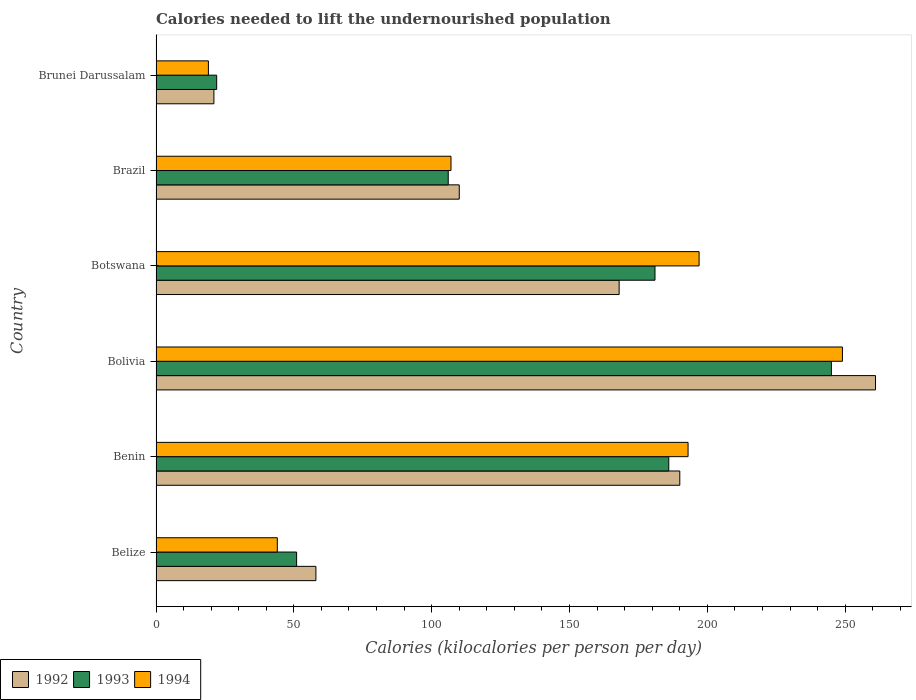How many different coloured bars are there?
Give a very brief answer. 3. How many groups of bars are there?
Keep it short and to the point. 6. Are the number of bars per tick equal to the number of legend labels?
Offer a terse response. Yes. Are the number of bars on each tick of the Y-axis equal?
Ensure brevity in your answer.  Yes. How many bars are there on the 3rd tick from the top?
Give a very brief answer. 3. What is the label of the 6th group of bars from the top?
Give a very brief answer. Belize. In how many cases, is the number of bars for a given country not equal to the number of legend labels?
Offer a terse response. 0. What is the total calories needed to lift the undernourished population in 1993 in Belize?
Offer a very short reply. 51. Across all countries, what is the maximum total calories needed to lift the undernourished population in 1993?
Ensure brevity in your answer.  245. In which country was the total calories needed to lift the undernourished population in 1994 maximum?
Offer a terse response. Bolivia. In which country was the total calories needed to lift the undernourished population in 1993 minimum?
Provide a succinct answer. Brunei Darussalam. What is the total total calories needed to lift the undernourished population in 1994 in the graph?
Give a very brief answer. 809. What is the difference between the total calories needed to lift the undernourished population in 1992 in Belize and that in Botswana?
Provide a short and direct response. -110. What is the difference between the total calories needed to lift the undernourished population in 1993 in Bolivia and the total calories needed to lift the undernourished population in 1994 in Belize?
Provide a short and direct response. 201. What is the average total calories needed to lift the undernourished population in 1994 per country?
Provide a succinct answer. 134.83. What is the ratio of the total calories needed to lift the undernourished population in 1994 in Benin to that in Brazil?
Your answer should be very brief. 1.8. What is the difference between the highest and the lowest total calories needed to lift the undernourished population in 1994?
Offer a terse response. 230. In how many countries, is the total calories needed to lift the undernourished population in 1994 greater than the average total calories needed to lift the undernourished population in 1994 taken over all countries?
Make the answer very short. 3. Is the sum of the total calories needed to lift the undernourished population in 1994 in Belize and Brunei Darussalam greater than the maximum total calories needed to lift the undernourished population in 1992 across all countries?
Provide a short and direct response. No. What does the 1st bar from the top in Botswana represents?
Provide a succinct answer. 1994. What does the 1st bar from the bottom in Botswana represents?
Make the answer very short. 1992. Is it the case that in every country, the sum of the total calories needed to lift the undernourished population in 1992 and total calories needed to lift the undernourished population in 1994 is greater than the total calories needed to lift the undernourished population in 1993?
Offer a very short reply. Yes. How many countries are there in the graph?
Your answer should be compact. 6. What is the difference between two consecutive major ticks on the X-axis?
Offer a very short reply. 50. Does the graph contain grids?
Keep it short and to the point. No. How are the legend labels stacked?
Provide a short and direct response. Horizontal. What is the title of the graph?
Give a very brief answer. Calories needed to lift the undernourished population. What is the label or title of the X-axis?
Offer a terse response. Calories (kilocalories per person per day). What is the Calories (kilocalories per person per day) of 1992 in Belize?
Your response must be concise. 58. What is the Calories (kilocalories per person per day) of 1994 in Belize?
Give a very brief answer. 44. What is the Calories (kilocalories per person per day) in 1992 in Benin?
Your answer should be very brief. 190. What is the Calories (kilocalories per person per day) of 1993 in Benin?
Provide a succinct answer. 186. What is the Calories (kilocalories per person per day) in 1994 in Benin?
Give a very brief answer. 193. What is the Calories (kilocalories per person per day) in 1992 in Bolivia?
Offer a terse response. 261. What is the Calories (kilocalories per person per day) in 1993 in Bolivia?
Ensure brevity in your answer.  245. What is the Calories (kilocalories per person per day) in 1994 in Bolivia?
Offer a very short reply. 249. What is the Calories (kilocalories per person per day) of 1992 in Botswana?
Offer a very short reply. 168. What is the Calories (kilocalories per person per day) of 1993 in Botswana?
Your answer should be very brief. 181. What is the Calories (kilocalories per person per day) of 1994 in Botswana?
Provide a succinct answer. 197. What is the Calories (kilocalories per person per day) of 1992 in Brazil?
Your response must be concise. 110. What is the Calories (kilocalories per person per day) of 1993 in Brazil?
Your response must be concise. 106. What is the Calories (kilocalories per person per day) of 1994 in Brazil?
Your response must be concise. 107. Across all countries, what is the maximum Calories (kilocalories per person per day) of 1992?
Keep it short and to the point. 261. Across all countries, what is the maximum Calories (kilocalories per person per day) of 1993?
Give a very brief answer. 245. Across all countries, what is the maximum Calories (kilocalories per person per day) in 1994?
Make the answer very short. 249. Across all countries, what is the minimum Calories (kilocalories per person per day) of 1993?
Ensure brevity in your answer.  22. What is the total Calories (kilocalories per person per day) in 1992 in the graph?
Offer a terse response. 808. What is the total Calories (kilocalories per person per day) in 1993 in the graph?
Your response must be concise. 791. What is the total Calories (kilocalories per person per day) of 1994 in the graph?
Provide a succinct answer. 809. What is the difference between the Calories (kilocalories per person per day) in 1992 in Belize and that in Benin?
Provide a short and direct response. -132. What is the difference between the Calories (kilocalories per person per day) in 1993 in Belize and that in Benin?
Provide a succinct answer. -135. What is the difference between the Calories (kilocalories per person per day) in 1994 in Belize and that in Benin?
Offer a very short reply. -149. What is the difference between the Calories (kilocalories per person per day) of 1992 in Belize and that in Bolivia?
Give a very brief answer. -203. What is the difference between the Calories (kilocalories per person per day) of 1993 in Belize and that in Bolivia?
Your answer should be compact. -194. What is the difference between the Calories (kilocalories per person per day) in 1994 in Belize and that in Bolivia?
Ensure brevity in your answer.  -205. What is the difference between the Calories (kilocalories per person per day) of 1992 in Belize and that in Botswana?
Give a very brief answer. -110. What is the difference between the Calories (kilocalories per person per day) in 1993 in Belize and that in Botswana?
Provide a short and direct response. -130. What is the difference between the Calories (kilocalories per person per day) in 1994 in Belize and that in Botswana?
Offer a very short reply. -153. What is the difference between the Calories (kilocalories per person per day) of 1992 in Belize and that in Brazil?
Your answer should be very brief. -52. What is the difference between the Calories (kilocalories per person per day) in 1993 in Belize and that in Brazil?
Your answer should be compact. -55. What is the difference between the Calories (kilocalories per person per day) of 1994 in Belize and that in Brazil?
Provide a succinct answer. -63. What is the difference between the Calories (kilocalories per person per day) in 1993 in Belize and that in Brunei Darussalam?
Offer a terse response. 29. What is the difference between the Calories (kilocalories per person per day) in 1992 in Benin and that in Bolivia?
Offer a terse response. -71. What is the difference between the Calories (kilocalories per person per day) in 1993 in Benin and that in Bolivia?
Give a very brief answer. -59. What is the difference between the Calories (kilocalories per person per day) of 1994 in Benin and that in Bolivia?
Your answer should be very brief. -56. What is the difference between the Calories (kilocalories per person per day) in 1992 in Benin and that in Botswana?
Provide a succinct answer. 22. What is the difference between the Calories (kilocalories per person per day) of 1993 in Benin and that in Botswana?
Keep it short and to the point. 5. What is the difference between the Calories (kilocalories per person per day) in 1993 in Benin and that in Brazil?
Provide a short and direct response. 80. What is the difference between the Calories (kilocalories per person per day) in 1992 in Benin and that in Brunei Darussalam?
Make the answer very short. 169. What is the difference between the Calories (kilocalories per person per day) of 1993 in Benin and that in Brunei Darussalam?
Your answer should be compact. 164. What is the difference between the Calories (kilocalories per person per day) of 1994 in Benin and that in Brunei Darussalam?
Offer a very short reply. 174. What is the difference between the Calories (kilocalories per person per day) of 1992 in Bolivia and that in Botswana?
Make the answer very short. 93. What is the difference between the Calories (kilocalories per person per day) of 1993 in Bolivia and that in Botswana?
Offer a terse response. 64. What is the difference between the Calories (kilocalories per person per day) in 1992 in Bolivia and that in Brazil?
Your answer should be very brief. 151. What is the difference between the Calories (kilocalories per person per day) in 1993 in Bolivia and that in Brazil?
Provide a succinct answer. 139. What is the difference between the Calories (kilocalories per person per day) of 1994 in Bolivia and that in Brazil?
Keep it short and to the point. 142. What is the difference between the Calories (kilocalories per person per day) of 1992 in Bolivia and that in Brunei Darussalam?
Make the answer very short. 240. What is the difference between the Calories (kilocalories per person per day) of 1993 in Bolivia and that in Brunei Darussalam?
Offer a very short reply. 223. What is the difference between the Calories (kilocalories per person per day) in 1994 in Bolivia and that in Brunei Darussalam?
Offer a terse response. 230. What is the difference between the Calories (kilocalories per person per day) in 1993 in Botswana and that in Brazil?
Your answer should be compact. 75. What is the difference between the Calories (kilocalories per person per day) in 1992 in Botswana and that in Brunei Darussalam?
Ensure brevity in your answer.  147. What is the difference between the Calories (kilocalories per person per day) in 1993 in Botswana and that in Brunei Darussalam?
Keep it short and to the point. 159. What is the difference between the Calories (kilocalories per person per day) in 1994 in Botswana and that in Brunei Darussalam?
Your response must be concise. 178. What is the difference between the Calories (kilocalories per person per day) in 1992 in Brazil and that in Brunei Darussalam?
Make the answer very short. 89. What is the difference between the Calories (kilocalories per person per day) of 1992 in Belize and the Calories (kilocalories per person per day) of 1993 in Benin?
Your answer should be compact. -128. What is the difference between the Calories (kilocalories per person per day) of 1992 in Belize and the Calories (kilocalories per person per day) of 1994 in Benin?
Provide a short and direct response. -135. What is the difference between the Calories (kilocalories per person per day) in 1993 in Belize and the Calories (kilocalories per person per day) in 1994 in Benin?
Make the answer very short. -142. What is the difference between the Calories (kilocalories per person per day) of 1992 in Belize and the Calories (kilocalories per person per day) of 1993 in Bolivia?
Offer a terse response. -187. What is the difference between the Calories (kilocalories per person per day) of 1992 in Belize and the Calories (kilocalories per person per day) of 1994 in Bolivia?
Your answer should be very brief. -191. What is the difference between the Calories (kilocalories per person per day) of 1993 in Belize and the Calories (kilocalories per person per day) of 1994 in Bolivia?
Provide a succinct answer. -198. What is the difference between the Calories (kilocalories per person per day) of 1992 in Belize and the Calories (kilocalories per person per day) of 1993 in Botswana?
Ensure brevity in your answer.  -123. What is the difference between the Calories (kilocalories per person per day) in 1992 in Belize and the Calories (kilocalories per person per day) in 1994 in Botswana?
Make the answer very short. -139. What is the difference between the Calories (kilocalories per person per day) in 1993 in Belize and the Calories (kilocalories per person per day) in 1994 in Botswana?
Your answer should be compact. -146. What is the difference between the Calories (kilocalories per person per day) of 1992 in Belize and the Calories (kilocalories per person per day) of 1993 in Brazil?
Offer a very short reply. -48. What is the difference between the Calories (kilocalories per person per day) of 1992 in Belize and the Calories (kilocalories per person per day) of 1994 in Brazil?
Provide a succinct answer. -49. What is the difference between the Calories (kilocalories per person per day) of 1993 in Belize and the Calories (kilocalories per person per day) of 1994 in Brazil?
Provide a succinct answer. -56. What is the difference between the Calories (kilocalories per person per day) of 1992 in Belize and the Calories (kilocalories per person per day) of 1994 in Brunei Darussalam?
Ensure brevity in your answer.  39. What is the difference between the Calories (kilocalories per person per day) of 1993 in Belize and the Calories (kilocalories per person per day) of 1994 in Brunei Darussalam?
Your response must be concise. 32. What is the difference between the Calories (kilocalories per person per day) in 1992 in Benin and the Calories (kilocalories per person per day) in 1993 in Bolivia?
Your answer should be compact. -55. What is the difference between the Calories (kilocalories per person per day) in 1992 in Benin and the Calories (kilocalories per person per day) in 1994 in Bolivia?
Make the answer very short. -59. What is the difference between the Calories (kilocalories per person per day) of 1993 in Benin and the Calories (kilocalories per person per day) of 1994 in Bolivia?
Your answer should be compact. -63. What is the difference between the Calories (kilocalories per person per day) of 1992 in Benin and the Calories (kilocalories per person per day) of 1993 in Botswana?
Make the answer very short. 9. What is the difference between the Calories (kilocalories per person per day) of 1993 in Benin and the Calories (kilocalories per person per day) of 1994 in Botswana?
Keep it short and to the point. -11. What is the difference between the Calories (kilocalories per person per day) of 1993 in Benin and the Calories (kilocalories per person per day) of 1994 in Brazil?
Your answer should be compact. 79. What is the difference between the Calories (kilocalories per person per day) in 1992 in Benin and the Calories (kilocalories per person per day) in 1993 in Brunei Darussalam?
Give a very brief answer. 168. What is the difference between the Calories (kilocalories per person per day) of 1992 in Benin and the Calories (kilocalories per person per day) of 1994 in Brunei Darussalam?
Provide a short and direct response. 171. What is the difference between the Calories (kilocalories per person per day) of 1993 in Benin and the Calories (kilocalories per person per day) of 1994 in Brunei Darussalam?
Your answer should be very brief. 167. What is the difference between the Calories (kilocalories per person per day) of 1992 in Bolivia and the Calories (kilocalories per person per day) of 1994 in Botswana?
Offer a terse response. 64. What is the difference between the Calories (kilocalories per person per day) in 1992 in Bolivia and the Calories (kilocalories per person per day) in 1993 in Brazil?
Make the answer very short. 155. What is the difference between the Calories (kilocalories per person per day) of 1992 in Bolivia and the Calories (kilocalories per person per day) of 1994 in Brazil?
Keep it short and to the point. 154. What is the difference between the Calories (kilocalories per person per day) in 1993 in Bolivia and the Calories (kilocalories per person per day) in 1994 in Brazil?
Your response must be concise. 138. What is the difference between the Calories (kilocalories per person per day) in 1992 in Bolivia and the Calories (kilocalories per person per day) in 1993 in Brunei Darussalam?
Keep it short and to the point. 239. What is the difference between the Calories (kilocalories per person per day) of 1992 in Bolivia and the Calories (kilocalories per person per day) of 1994 in Brunei Darussalam?
Ensure brevity in your answer.  242. What is the difference between the Calories (kilocalories per person per day) in 1993 in Bolivia and the Calories (kilocalories per person per day) in 1994 in Brunei Darussalam?
Your answer should be very brief. 226. What is the difference between the Calories (kilocalories per person per day) of 1992 in Botswana and the Calories (kilocalories per person per day) of 1993 in Brunei Darussalam?
Ensure brevity in your answer.  146. What is the difference between the Calories (kilocalories per person per day) of 1992 in Botswana and the Calories (kilocalories per person per day) of 1994 in Brunei Darussalam?
Ensure brevity in your answer.  149. What is the difference between the Calories (kilocalories per person per day) in 1993 in Botswana and the Calories (kilocalories per person per day) in 1994 in Brunei Darussalam?
Provide a short and direct response. 162. What is the difference between the Calories (kilocalories per person per day) of 1992 in Brazil and the Calories (kilocalories per person per day) of 1994 in Brunei Darussalam?
Keep it short and to the point. 91. What is the difference between the Calories (kilocalories per person per day) in 1993 in Brazil and the Calories (kilocalories per person per day) in 1994 in Brunei Darussalam?
Offer a terse response. 87. What is the average Calories (kilocalories per person per day) of 1992 per country?
Your answer should be very brief. 134.67. What is the average Calories (kilocalories per person per day) in 1993 per country?
Provide a succinct answer. 131.83. What is the average Calories (kilocalories per person per day) in 1994 per country?
Keep it short and to the point. 134.83. What is the difference between the Calories (kilocalories per person per day) of 1992 and Calories (kilocalories per person per day) of 1993 in Belize?
Ensure brevity in your answer.  7. What is the difference between the Calories (kilocalories per person per day) in 1992 and Calories (kilocalories per person per day) in 1994 in Belize?
Offer a terse response. 14. What is the difference between the Calories (kilocalories per person per day) of 1993 and Calories (kilocalories per person per day) of 1994 in Belize?
Keep it short and to the point. 7. What is the difference between the Calories (kilocalories per person per day) of 1992 and Calories (kilocalories per person per day) of 1994 in Benin?
Give a very brief answer. -3. What is the difference between the Calories (kilocalories per person per day) of 1993 and Calories (kilocalories per person per day) of 1994 in Benin?
Offer a terse response. -7. What is the difference between the Calories (kilocalories per person per day) of 1992 and Calories (kilocalories per person per day) of 1993 in Bolivia?
Make the answer very short. 16. What is the difference between the Calories (kilocalories per person per day) of 1992 and Calories (kilocalories per person per day) of 1993 in Brazil?
Provide a succinct answer. 4. What is the difference between the Calories (kilocalories per person per day) of 1993 and Calories (kilocalories per person per day) of 1994 in Brazil?
Make the answer very short. -1. What is the difference between the Calories (kilocalories per person per day) of 1992 and Calories (kilocalories per person per day) of 1993 in Brunei Darussalam?
Offer a terse response. -1. What is the difference between the Calories (kilocalories per person per day) of 1993 and Calories (kilocalories per person per day) of 1994 in Brunei Darussalam?
Ensure brevity in your answer.  3. What is the ratio of the Calories (kilocalories per person per day) of 1992 in Belize to that in Benin?
Provide a short and direct response. 0.31. What is the ratio of the Calories (kilocalories per person per day) in 1993 in Belize to that in Benin?
Offer a very short reply. 0.27. What is the ratio of the Calories (kilocalories per person per day) in 1994 in Belize to that in Benin?
Provide a succinct answer. 0.23. What is the ratio of the Calories (kilocalories per person per day) in 1992 in Belize to that in Bolivia?
Give a very brief answer. 0.22. What is the ratio of the Calories (kilocalories per person per day) of 1993 in Belize to that in Bolivia?
Your response must be concise. 0.21. What is the ratio of the Calories (kilocalories per person per day) of 1994 in Belize to that in Bolivia?
Give a very brief answer. 0.18. What is the ratio of the Calories (kilocalories per person per day) of 1992 in Belize to that in Botswana?
Provide a short and direct response. 0.35. What is the ratio of the Calories (kilocalories per person per day) in 1993 in Belize to that in Botswana?
Provide a short and direct response. 0.28. What is the ratio of the Calories (kilocalories per person per day) of 1994 in Belize to that in Botswana?
Provide a short and direct response. 0.22. What is the ratio of the Calories (kilocalories per person per day) in 1992 in Belize to that in Brazil?
Give a very brief answer. 0.53. What is the ratio of the Calories (kilocalories per person per day) of 1993 in Belize to that in Brazil?
Give a very brief answer. 0.48. What is the ratio of the Calories (kilocalories per person per day) in 1994 in Belize to that in Brazil?
Provide a short and direct response. 0.41. What is the ratio of the Calories (kilocalories per person per day) of 1992 in Belize to that in Brunei Darussalam?
Make the answer very short. 2.76. What is the ratio of the Calories (kilocalories per person per day) in 1993 in Belize to that in Brunei Darussalam?
Make the answer very short. 2.32. What is the ratio of the Calories (kilocalories per person per day) in 1994 in Belize to that in Brunei Darussalam?
Your answer should be very brief. 2.32. What is the ratio of the Calories (kilocalories per person per day) of 1992 in Benin to that in Bolivia?
Your answer should be compact. 0.73. What is the ratio of the Calories (kilocalories per person per day) in 1993 in Benin to that in Bolivia?
Provide a short and direct response. 0.76. What is the ratio of the Calories (kilocalories per person per day) of 1994 in Benin to that in Bolivia?
Offer a very short reply. 0.78. What is the ratio of the Calories (kilocalories per person per day) in 1992 in Benin to that in Botswana?
Make the answer very short. 1.13. What is the ratio of the Calories (kilocalories per person per day) of 1993 in Benin to that in Botswana?
Offer a terse response. 1.03. What is the ratio of the Calories (kilocalories per person per day) of 1994 in Benin to that in Botswana?
Offer a terse response. 0.98. What is the ratio of the Calories (kilocalories per person per day) in 1992 in Benin to that in Brazil?
Your answer should be compact. 1.73. What is the ratio of the Calories (kilocalories per person per day) in 1993 in Benin to that in Brazil?
Your response must be concise. 1.75. What is the ratio of the Calories (kilocalories per person per day) of 1994 in Benin to that in Brazil?
Make the answer very short. 1.8. What is the ratio of the Calories (kilocalories per person per day) of 1992 in Benin to that in Brunei Darussalam?
Your response must be concise. 9.05. What is the ratio of the Calories (kilocalories per person per day) of 1993 in Benin to that in Brunei Darussalam?
Provide a short and direct response. 8.45. What is the ratio of the Calories (kilocalories per person per day) in 1994 in Benin to that in Brunei Darussalam?
Keep it short and to the point. 10.16. What is the ratio of the Calories (kilocalories per person per day) in 1992 in Bolivia to that in Botswana?
Your response must be concise. 1.55. What is the ratio of the Calories (kilocalories per person per day) in 1993 in Bolivia to that in Botswana?
Your response must be concise. 1.35. What is the ratio of the Calories (kilocalories per person per day) of 1994 in Bolivia to that in Botswana?
Provide a short and direct response. 1.26. What is the ratio of the Calories (kilocalories per person per day) in 1992 in Bolivia to that in Brazil?
Ensure brevity in your answer.  2.37. What is the ratio of the Calories (kilocalories per person per day) of 1993 in Bolivia to that in Brazil?
Your answer should be compact. 2.31. What is the ratio of the Calories (kilocalories per person per day) in 1994 in Bolivia to that in Brazil?
Make the answer very short. 2.33. What is the ratio of the Calories (kilocalories per person per day) in 1992 in Bolivia to that in Brunei Darussalam?
Your answer should be compact. 12.43. What is the ratio of the Calories (kilocalories per person per day) of 1993 in Bolivia to that in Brunei Darussalam?
Make the answer very short. 11.14. What is the ratio of the Calories (kilocalories per person per day) in 1994 in Bolivia to that in Brunei Darussalam?
Give a very brief answer. 13.11. What is the ratio of the Calories (kilocalories per person per day) of 1992 in Botswana to that in Brazil?
Ensure brevity in your answer.  1.53. What is the ratio of the Calories (kilocalories per person per day) in 1993 in Botswana to that in Brazil?
Ensure brevity in your answer.  1.71. What is the ratio of the Calories (kilocalories per person per day) in 1994 in Botswana to that in Brazil?
Ensure brevity in your answer.  1.84. What is the ratio of the Calories (kilocalories per person per day) of 1992 in Botswana to that in Brunei Darussalam?
Your answer should be compact. 8. What is the ratio of the Calories (kilocalories per person per day) of 1993 in Botswana to that in Brunei Darussalam?
Offer a very short reply. 8.23. What is the ratio of the Calories (kilocalories per person per day) in 1994 in Botswana to that in Brunei Darussalam?
Keep it short and to the point. 10.37. What is the ratio of the Calories (kilocalories per person per day) in 1992 in Brazil to that in Brunei Darussalam?
Ensure brevity in your answer.  5.24. What is the ratio of the Calories (kilocalories per person per day) of 1993 in Brazil to that in Brunei Darussalam?
Your response must be concise. 4.82. What is the ratio of the Calories (kilocalories per person per day) of 1994 in Brazil to that in Brunei Darussalam?
Your answer should be very brief. 5.63. What is the difference between the highest and the second highest Calories (kilocalories per person per day) of 1992?
Your answer should be compact. 71. What is the difference between the highest and the second highest Calories (kilocalories per person per day) in 1994?
Your answer should be very brief. 52. What is the difference between the highest and the lowest Calories (kilocalories per person per day) of 1992?
Your response must be concise. 240. What is the difference between the highest and the lowest Calories (kilocalories per person per day) in 1993?
Offer a terse response. 223. What is the difference between the highest and the lowest Calories (kilocalories per person per day) of 1994?
Provide a succinct answer. 230. 